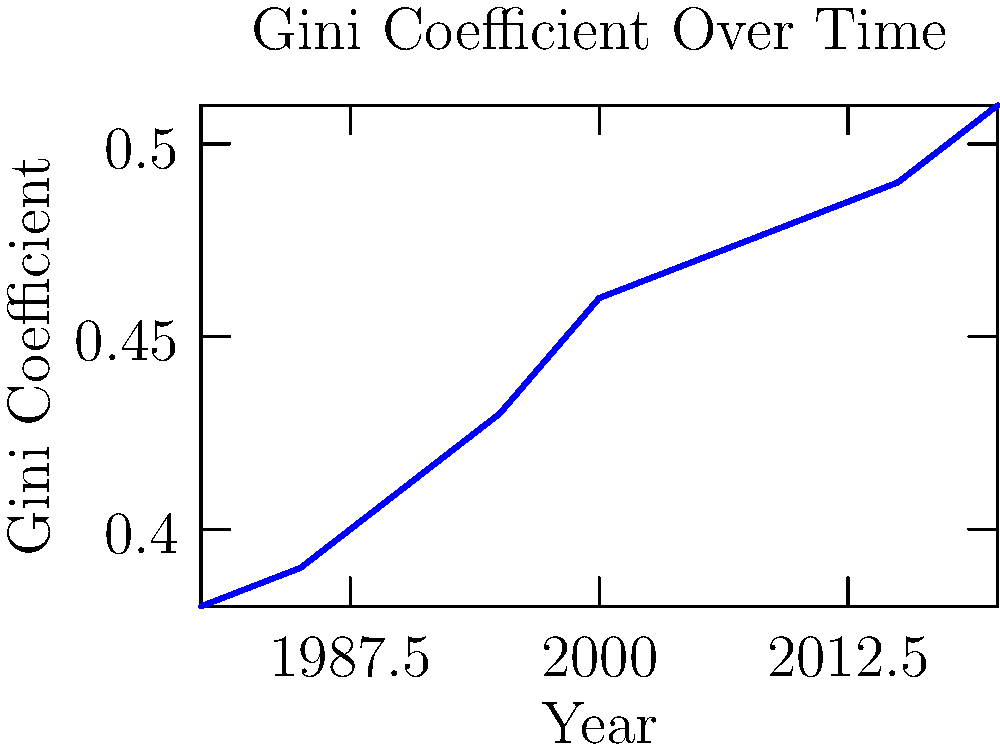Analyzing the graph of Gini coefficient changes over time, what economic implications can be drawn about wealth distribution, and how might this trend influence social stability? Propose a radical policy intervention that could potentially reverse this trend. 1. Observe the trend: The Gini coefficient has steadily increased from 0.38 in 1980 to 0.51 in 2020, indicating growing income inequality.

2. Economic implications:
   a) Widening wealth gap between rich and poor
   b) Potential decrease in economic mobility
   c) Possible concentration of economic power in fewer hands

3. Social stability concerns:
   a) Increased social tension and unrest
   b) Potential for political polarization
   c) Erosion of social cohesion and trust

4. Factors contributing to the trend:
   a) Globalization and technological advancements
   b) Changes in tax policies favoring the wealthy
   c) Decline in labor union power

5. Radical policy intervention proposal:
   a) Implement a progressive wealth tax
   b) Establish a universal basic income
   c) Mandate employee ownership in large corporations

6. Potential impacts of the intervention:
   a) Redistribution of wealth from top earners
   b) Increased economic security for lower-income individuals
   c) Broader participation in capital ownership

7. Challenges to implementation:
   a) Political resistance from wealthy individuals and corporations
   b) Potential capital flight or tax avoidance
   c) Balancing wealth redistribution with economic growth incentives

The proposed intervention aims to reverse the increasing Gini coefficient trend by directly addressing wealth concentration and providing a more equitable distribution of economic resources.
Answer: Progressive wealth tax, universal basic income, and mandated employee ownership to reverse rising inequality trend. 